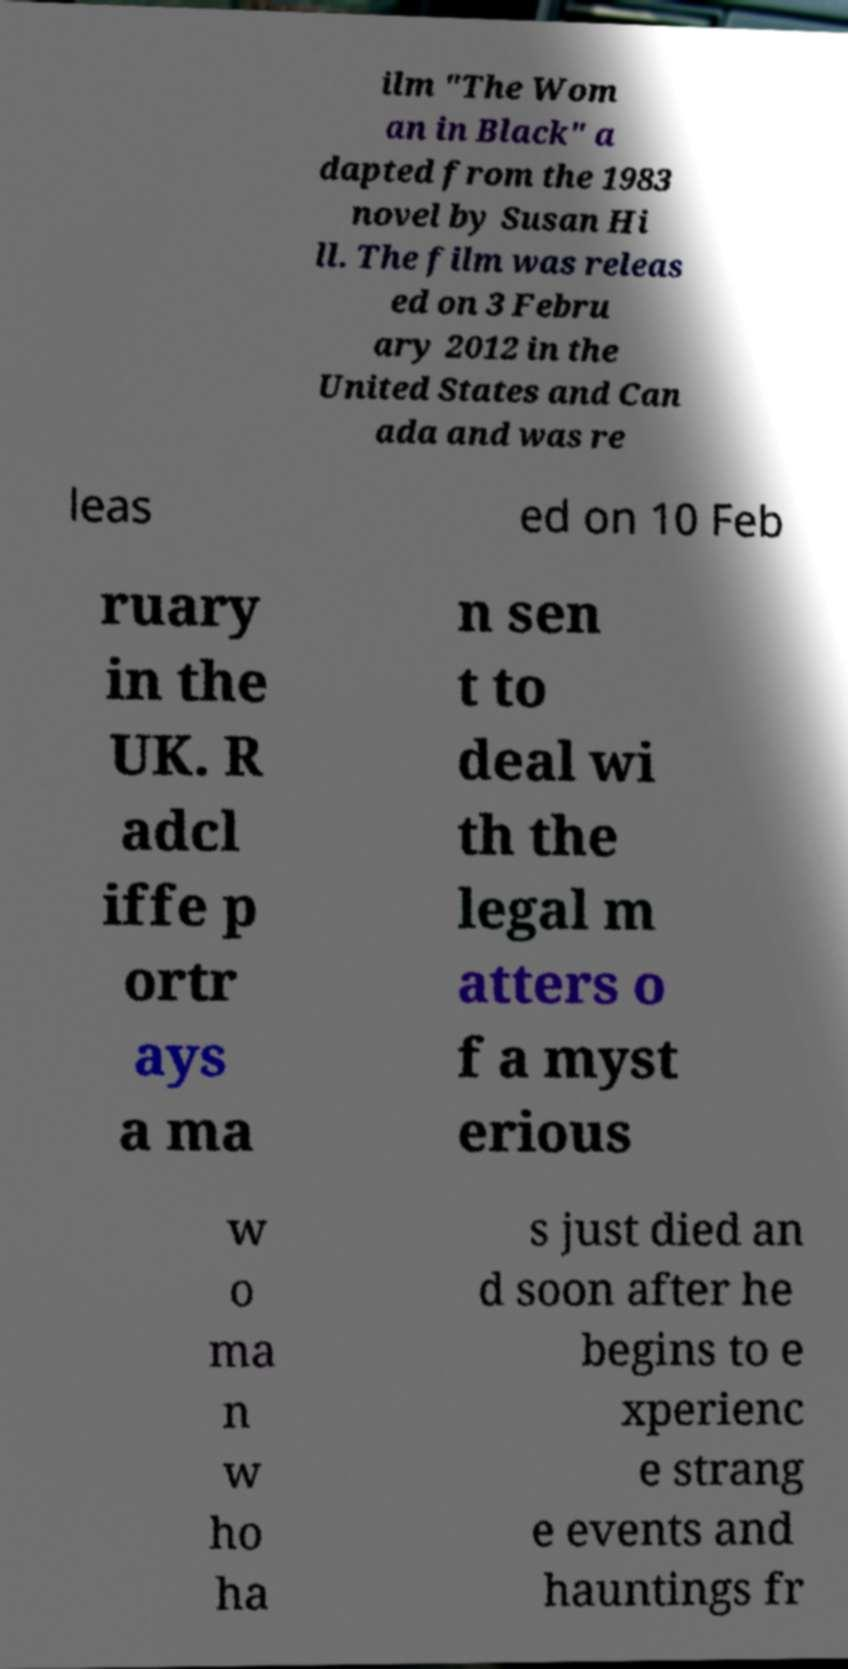There's text embedded in this image that I need extracted. Can you transcribe it verbatim? ilm "The Wom an in Black" a dapted from the 1983 novel by Susan Hi ll. The film was releas ed on 3 Febru ary 2012 in the United States and Can ada and was re leas ed on 10 Feb ruary in the UK. R adcl iffe p ortr ays a ma n sen t to deal wi th the legal m atters o f a myst erious w o ma n w ho ha s just died an d soon after he begins to e xperienc e strang e events and hauntings fr 